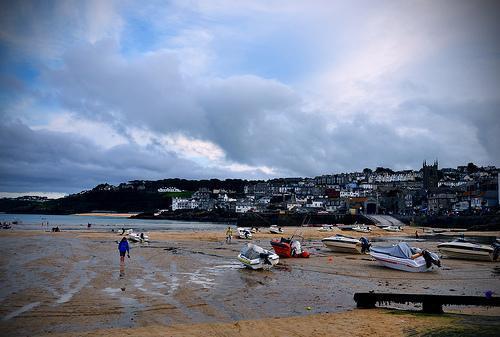How many people on the shore?
Give a very brief answer. 2. 